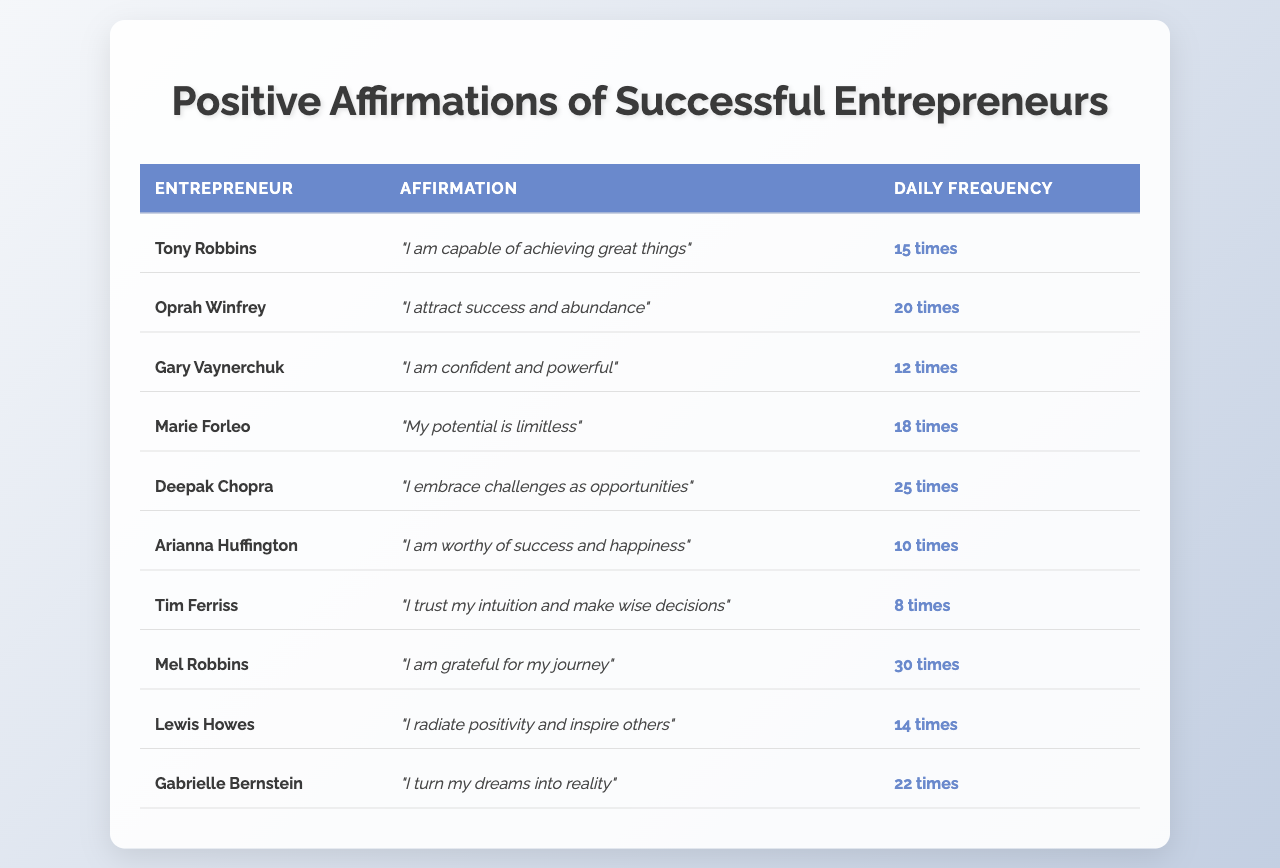What is the highest daily frequency of affirmations used by an entrepreneur? By looking at the "Daily Frequency" column in the table, the maximum value is 30, which corresponds to Mel Robbins.
Answer: 30 Which entrepreneur uses affirmations the least frequently? By examining the "Daily Frequency" column, the lowest frequency is 8, associated with Tim Ferriss.
Answer: Tim Ferriss What is the total daily frequency of affirmations by all entrepreneurs? Summing the daily frequency values: 15 + 20 + 12 + 18 + 25 + 10 + 8 + 30 + 14 + 22 = 180 gives the total frequency.
Answer: 180 How many entrepreneurs use affirmations 20 times or more? The table shows 5 entrepreneurs (Oprah Winfrey, Deepak Chopra, Mel Robbins, Gabrielle Bernstein) with a frequency of 20 or more.
Answer: 5 What is the average frequency of affirmations used by these entrepreneurs? The average frequency is calculated by dividing the total frequency (180) by the number of entrepreneurs (10), which equals 18.
Answer: 18 Is there an entrepreneur who uses the affirmation "I attract success and abundance"? Yes, Oprah Winfrey uses this specific affirmation as indicated in the "Affirmation" column.
Answer: Yes Which affirmation has the frequency of 10, and which entrepreneur uses it? The frequency of 10 is used by Arianna Huffington as per the table.
Answer: Arianna Huffington How does the frequency of affirmations used by Tony Robbins compare to that of Deepak Chopra? Tony Robbins uses 15 affirmations, while Deepak Chopra uses 25. Comparing these shows that Deepak Chopra uses 10 more affirmations than Tony Robbins.
Answer: Deepak Chopra uses 10 more affirmations Which entrepreneur's affirmation is "I radiate positivity and inspire others"? This affirmation is associated with Lewis Howes according to the data in the table.
Answer: Lewis Howes If an entrepreneur used their affirmations one time less daily, which entrepreneur would then have the lowest frequency? If Mel Robbins (30) were to use her affirmations one time less, her frequency would be 29, so Tim Ferriss (8) would still have the lowest frequency as 29 is higher.
Answer: Tim Ferriss still has the lowest frequency 